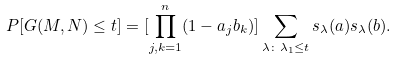Convert formula to latex. <formula><loc_0><loc_0><loc_500><loc_500>P [ G ( M , N ) \leq t ] = [ \prod _ { j , k = 1 } ^ { n } ( 1 - a _ { j } b _ { k } ) ] \sum _ { \lambda \colon \lambda _ { 1 } \leq t } s _ { \lambda } ( a ) s _ { \lambda } ( b ) .</formula> 